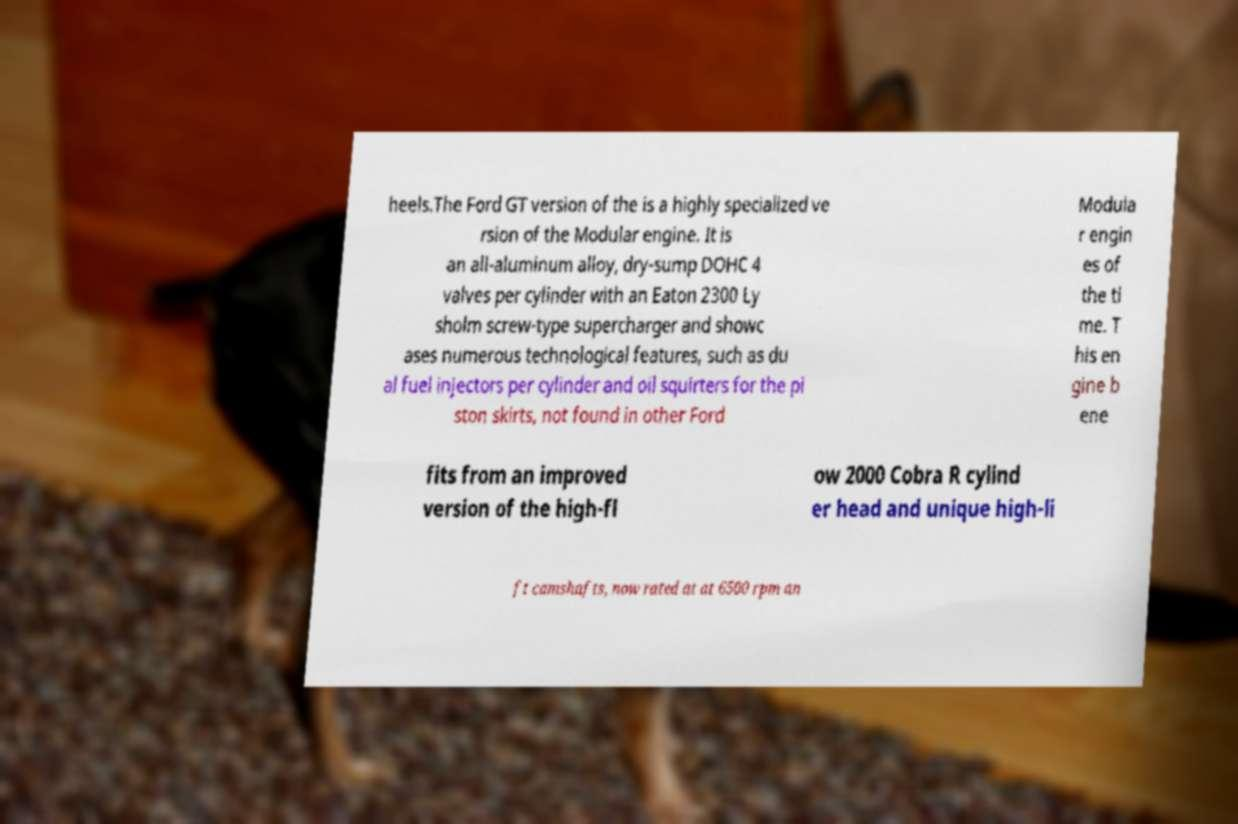For documentation purposes, I need the text within this image transcribed. Could you provide that? heels.The Ford GT version of the is a highly specialized ve rsion of the Modular engine. It is an all-aluminum alloy, dry-sump DOHC 4 valves per cylinder with an Eaton 2300 Ly sholm screw-type supercharger and showc ases numerous technological features, such as du al fuel injectors per cylinder and oil squirters for the pi ston skirts, not found in other Ford Modula r engin es of the ti me. T his en gine b ene fits from an improved version of the high-fl ow 2000 Cobra R cylind er head and unique high-li ft camshafts, now rated at at 6500 rpm an 